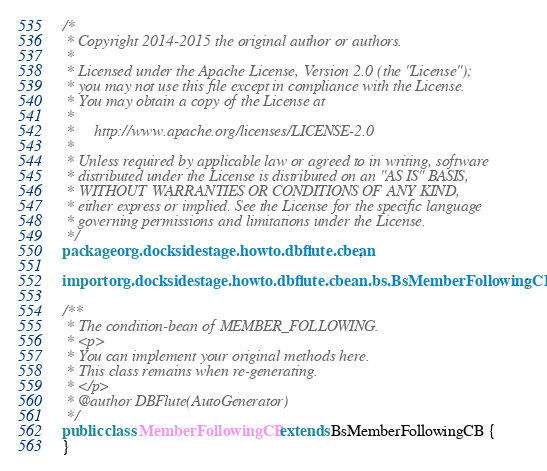<code> <loc_0><loc_0><loc_500><loc_500><_Java_>/*
 * Copyright 2014-2015 the original author or authors.
 *
 * Licensed under the Apache License, Version 2.0 (the "License");
 * you may not use this file except in compliance with the License.
 * You may obtain a copy of the License at
 *
 *     http://www.apache.org/licenses/LICENSE-2.0
 *
 * Unless required by applicable law or agreed to in writing, software
 * distributed under the License is distributed on an "AS IS" BASIS,
 * WITHOUT WARRANTIES OR CONDITIONS OF ANY KIND,
 * either express or implied. See the License for the specific language
 * governing permissions and limitations under the License.
 */
package org.docksidestage.howto.dbflute.cbean;

import org.docksidestage.howto.dbflute.cbean.bs.BsMemberFollowingCB;

/**
 * The condition-bean of MEMBER_FOLLOWING.
 * <p>
 * You can implement your original methods here.
 * This class remains when re-generating.
 * </p>
 * @author DBFlute(AutoGenerator)
 */
public class MemberFollowingCB extends BsMemberFollowingCB {
}
</code> 